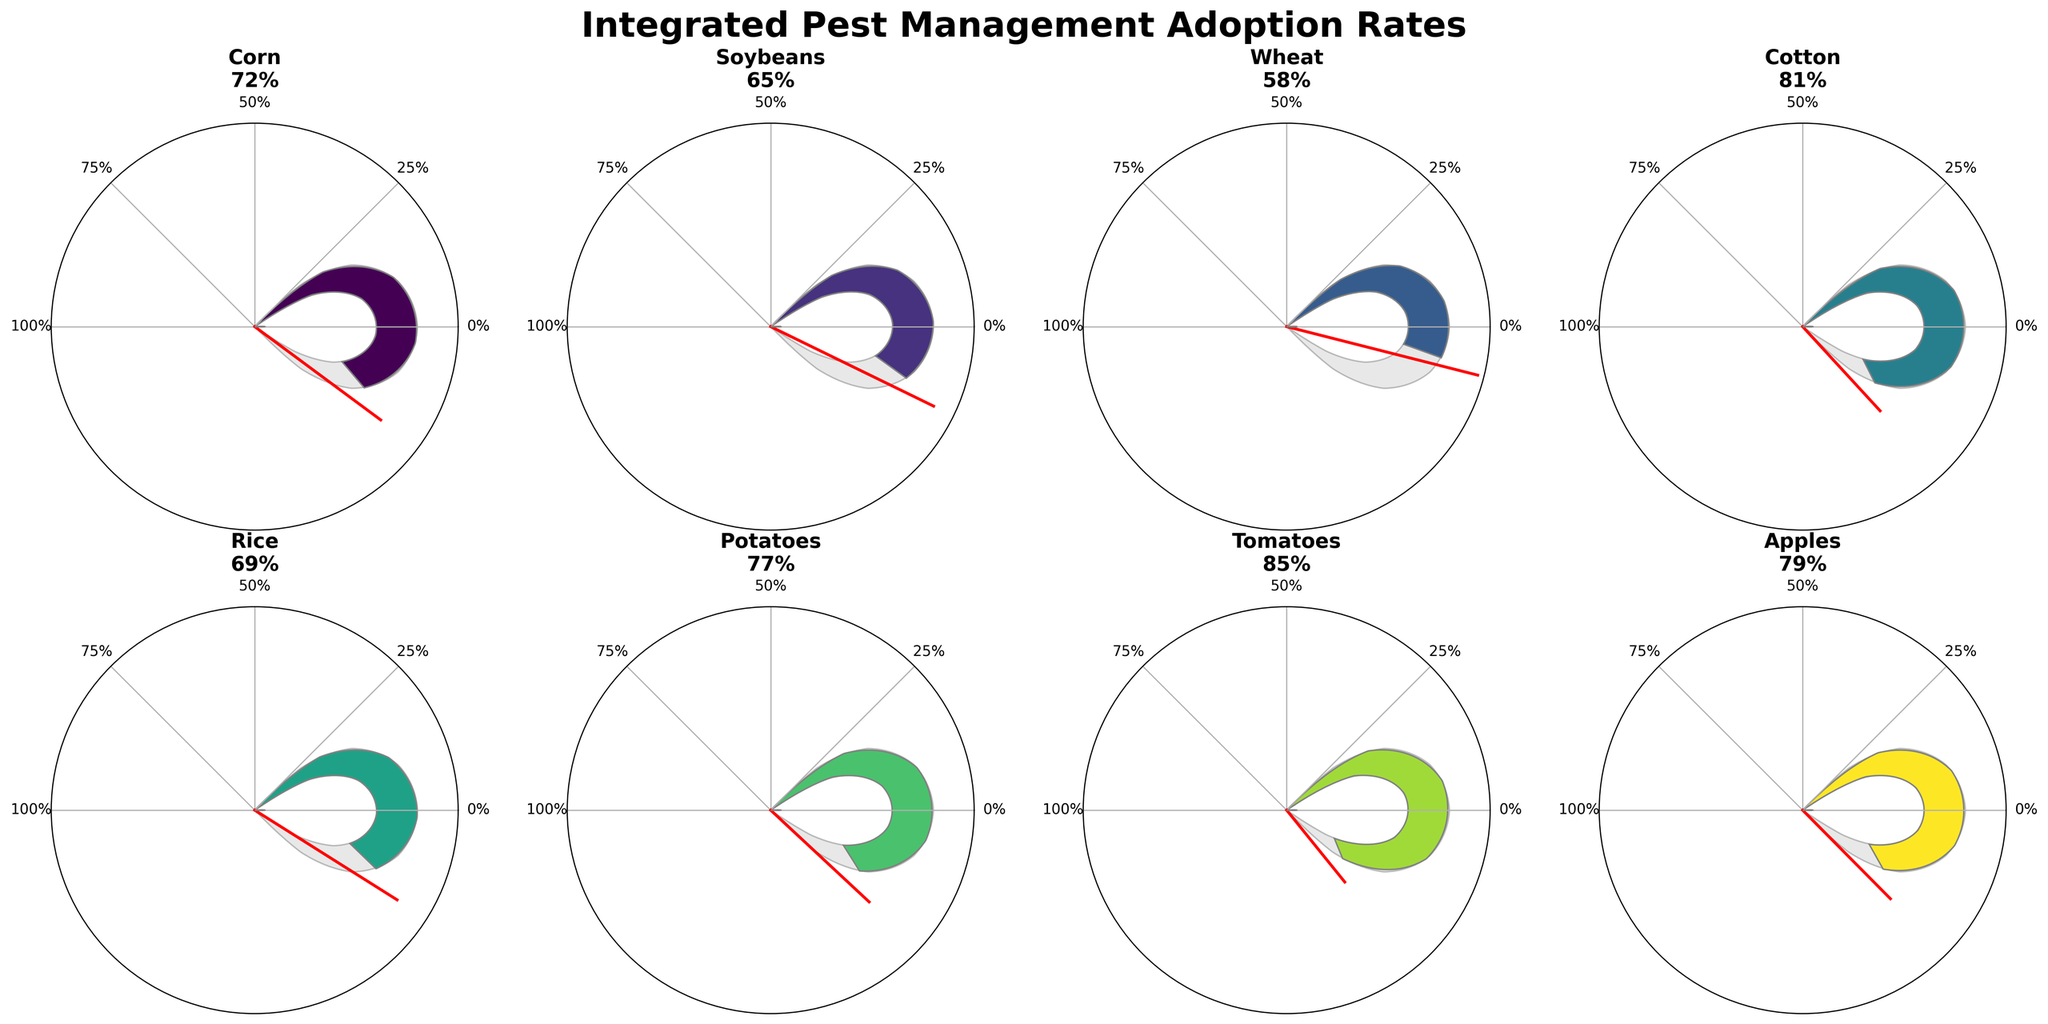What is the title of the figure? The title of the figure is displayed at the top and reads "Integrated Pest Management Adoption Rates."
Answer: Integrated Pest Management Adoption Rates How many different crops are shown in the figure? There are individual gauge charts for each crop. By counting, you can see that there are 8 crops shown in the figure.
Answer: 8 Which crop has the highest Integrated Pest Management (IPM) adoption rate? By observing each gauge chart, you can see that Tomatoes have the highest IPM adoption rate at 85%.
Answer: Tomatoes What is the average IPM adoption rate for the crops shown? To find the average, add all the rates: 72 (Corn) + 65 (Soybeans) + 58 (Wheat) + 81 (Cotton) + 69 (Rice) + 77 (Potatoes) + 85 (Tomatoes) + 79 (Apples) = 586. Then divide by the number of crops, which is 8. The average is 586 / 8 = 73.25%.
Answer: 73.25% Which crop has a higher IPM adoption rate, Corn or Soybeans? Looking at the specific gauges, Corn has a rate of 72%, and Soybeans have a rate of 65%. Therefore, Corn has a higher IPM adoption rate.
Answer: Corn How much higher is the adoption rate for Tomatoes compared to Wheat? The adoption rate for Tomatoes is 85%, and for Wheat, it is 58%. Subtracting these gives 85 - 58 = 27%. Tomatoes' adoption rate is 27% higher than Wheat's.
Answer: 27% What is the lowest IPM adoption rate shown and for which crop? By checking all gauges, you can see that Wheat has the lowest rate at 58%.
Answer: Wheat What is the median IPM adoption rate among these crops? To find the median, list out the rates in ascending order: 58, 65, 69, 72, 77, 79, 81, 85. There are 8 numbers, so the median is the average of the 4th and 5th numbers: (72 + 77) / 2 = 74.5%.
Answer: 74.5% Compare the IPM adoption rates for Cotton and Apples. Which is higher? Cotton has a rate of 81%, while Apples have a rate of 79%. Therefore, Cotton's rate is higher.
Answer: Cotton What is the total IPM adoption rate percentage when summed across all crops shown? Adding all the adoption rates together: 72 (Corn) + 65 (Soybeans) + 58 (Wheat) + 81 (Cotton) + 69 (Rice) + 77 (Potatoes) + 85 (Tomatoes) + 79 (Apples) = 586%.
Answer: 586% 